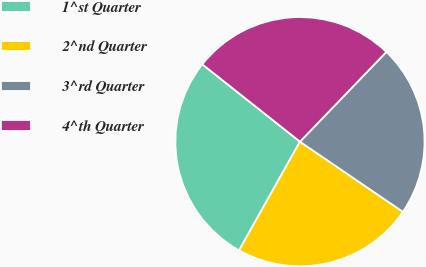<chart> <loc_0><loc_0><loc_500><loc_500><pie_chart><fcel>1^st Quarter<fcel>2^nd Quarter<fcel>3^rd Quarter<fcel>4^th Quarter<nl><fcel>27.54%<fcel>23.6%<fcel>22.32%<fcel>26.53%<nl></chart> 